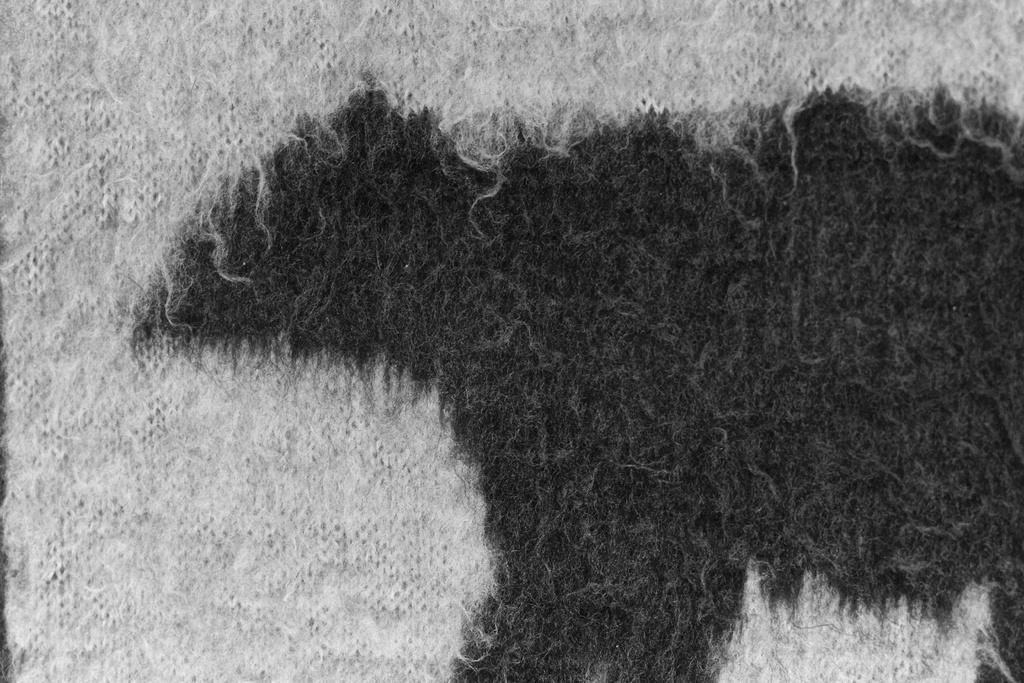Please provide a concise description of this image. In the picture we can see mat which is in white and black color. 